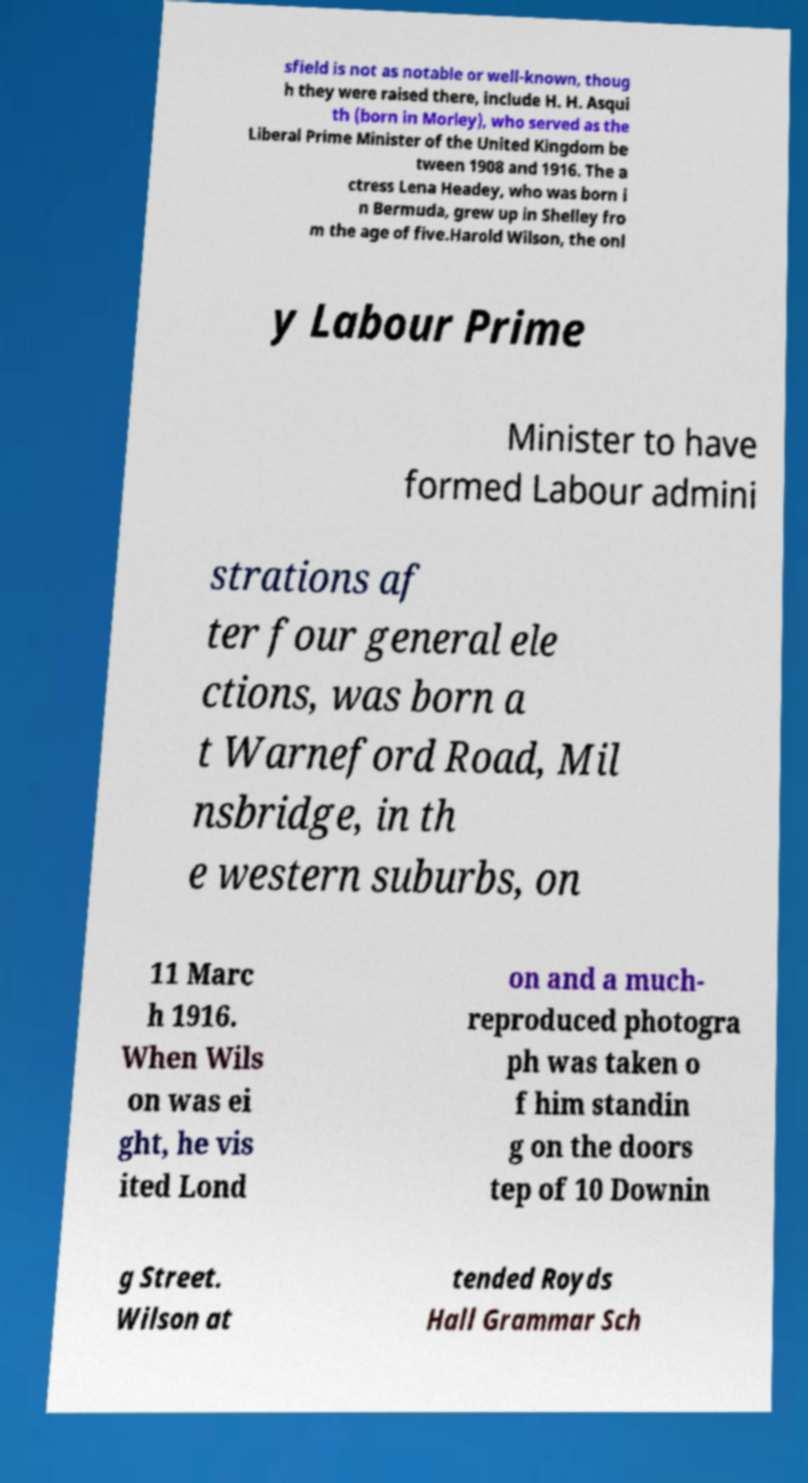What messages or text are displayed in this image? I need them in a readable, typed format. sfield is not as notable or well-known, thoug h they were raised there, include H. H. Asqui th (born in Morley), who served as the Liberal Prime Minister of the United Kingdom be tween 1908 and 1916. The a ctress Lena Headey, who was born i n Bermuda, grew up in Shelley fro m the age of five.Harold Wilson, the onl y Labour Prime Minister to have formed Labour admini strations af ter four general ele ctions, was born a t Warneford Road, Mil nsbridge, in th e western suburbs, on 11 Marc h 1916. When Wils on was ei ght, he vis ited Lond on and a much- reproduced photogra ph was taken o f him standin g on the doors tep of 10 Downin g Street. Wilson at tended Royds Hall Grammar Sch 